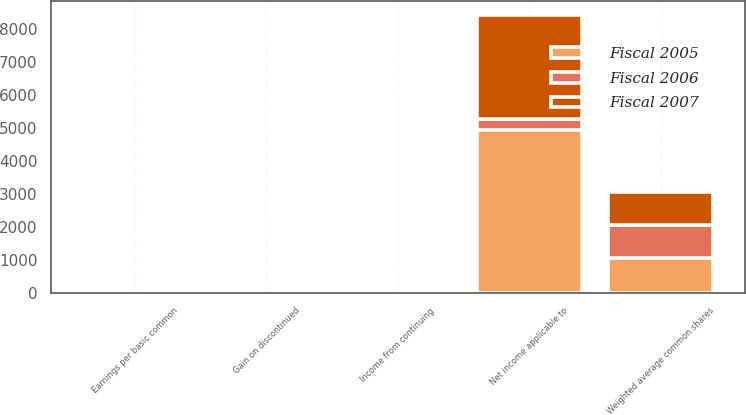<chart> <loc_0><loc_0><loc_500><loc_500><stacked_bar_chart><ecel><fcel>Income from continuing<fcel>Gain on discontinued<fcel>Net income applicable to<fcel>Weighted average common shares<fcel>Earnings per basic common<nl><fcel>Fiscal 2007<fcel>2.49<fcel>0.64<fcel>3141<fcel>1002<fcel>3.13<nl><fcel>Fiscal 2006<fcel>6.25<fcel>1.13<fcel>358<fcel>1010<fcel>7.38<nl><fcel>Fiscal 2005<fcel>4.32<fcel>0.33<fcel>4939<fcel>1050<fcel>4.7<nl></chart> 